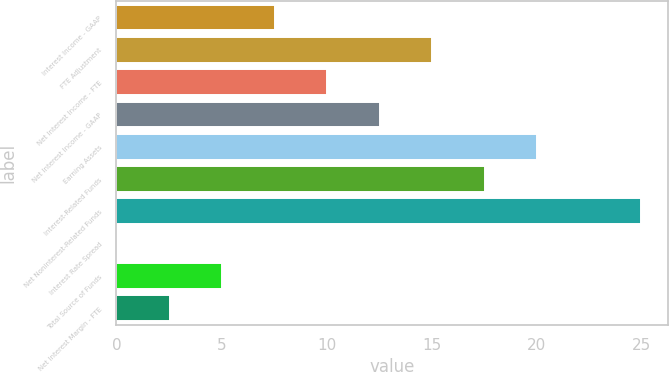Convert chart to OTSL. <chart><loc_0><loc_0><loc_500><loc_500><bar_chart><fcel>Interest Income - GAAP<fcel>FTE Adjustment<fcel>Net Interest Income - FTE<fcel>Net Interest Income - GAAP<fcel>Earning Assets<fcel>Interest-Related Funds<fcel>Net Noninterest-Related Funds<fcel>Interest Rate Spread<fcel>Total Source of Funds<fcel>Net Interest Margin - FTE<nl><fcel>7.54<fcel>15.04<fcel>10.04<fcel>12.54<fcel>20.04<fcel>17.54<fcel>25<fcel>0.04<fcel>5.04<fcel>2.54<nl></chart> 